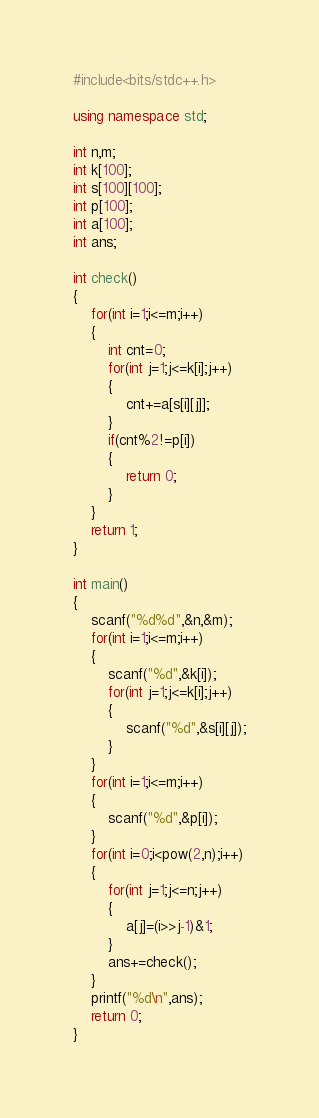<code> <loc_0><loc_0><loc_500><loc_500><_C++_>#include<bits/stdc++.h>

using namespace std;

int n,m; 
int k[100];
int s[100][100];
int p[100];
int a[100];
int ans;

int check()
{
	for(int i=1;i<=m;i++)
	{
		int cnt=0;
		for(int j=1;j<=k[i];j++)
		{
			cnt+=a[s[i][j]];
		}
		if(cnt%2!=p[i])
		{
			return 0;
		}
	}
	return 1;
}

int main()
{
	scanf("%d%d",&n,&m);
	for(int i=1;i<=m;i++)
	{
		scanf("%d",&k[i]);
		for(int j=1;j<=k[i];j++)
		{
			scanf("%d",&s[i][j]);
		}
	}
	for(int i=1;i<=m;i++)
	{
		scanf("%d",&p[i]);
	}
	for(int i=0;i<pow(2,n);i++)
	{
		for(int j=1;j<=n;j++)
		{
			a[j]=(i>>j-1)&1;
		}
		ans+=check();
	}
	printf("%d\n",ans);
	return 0;
}</code> 